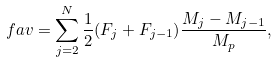Convert formula to latex. <formula><loc_0><loc_0><loc_500><loc_500>\ f a v = \sum ^ { N } _ { j = 2 } \frac { 1 } { 2 } ( F _ { j } + F _ { j - 1 } ) \frac { M _ { j } - M _ { j - 1 } } { M _ { p } } ,</formula> 